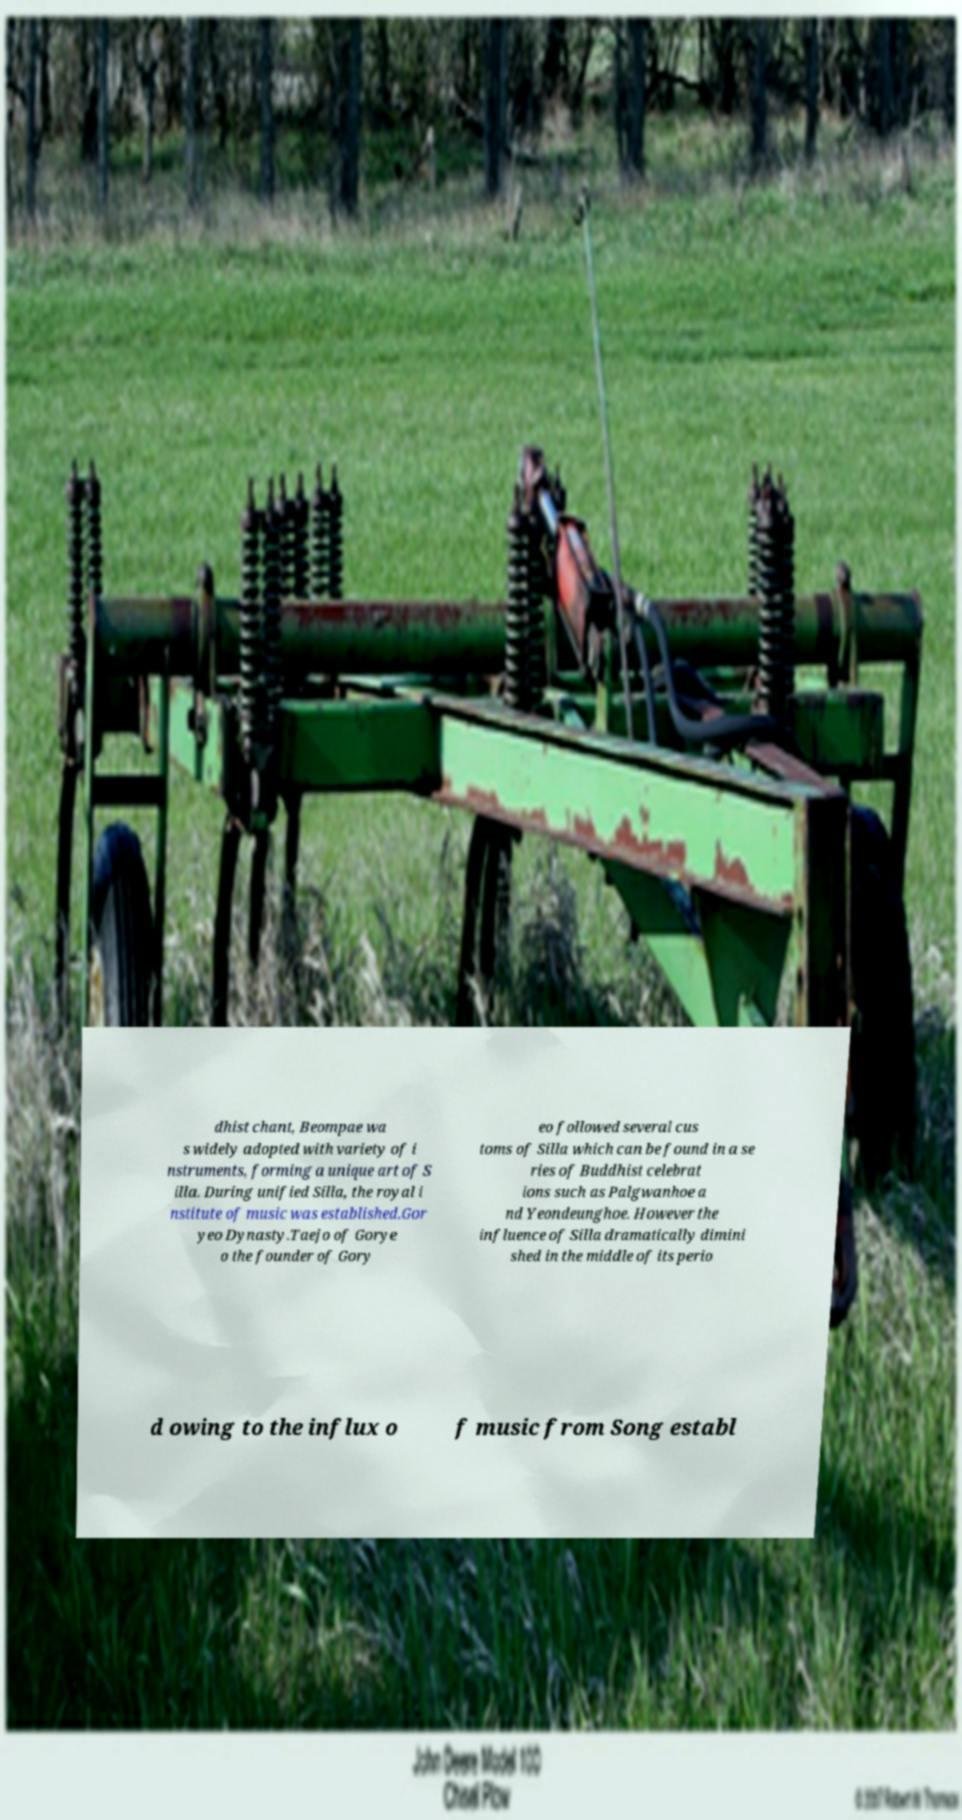Please identify and transcribe the text found in this image. dhist chant, Beompae wa s widely adopted with variety of i nstruments, forming a unique art of S illa. During unified Silla, the royal i nstitute of music was established.Gor yeo Dynasty.Taejo of Gorye o the founder of Gory eo followed several cus toms of Silla which can be found in a se ries of Buddhist celebrat ions such as Palgwanhoe a nd Yeondeunghoe. However the influence of Silla dramatically dimini shed in the middle of its perio d owing to the influx o f music from Song establ 